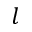Convert formula to latex. <formula><loc_0><loc_0><loc_500><loc_500>l</formula> 